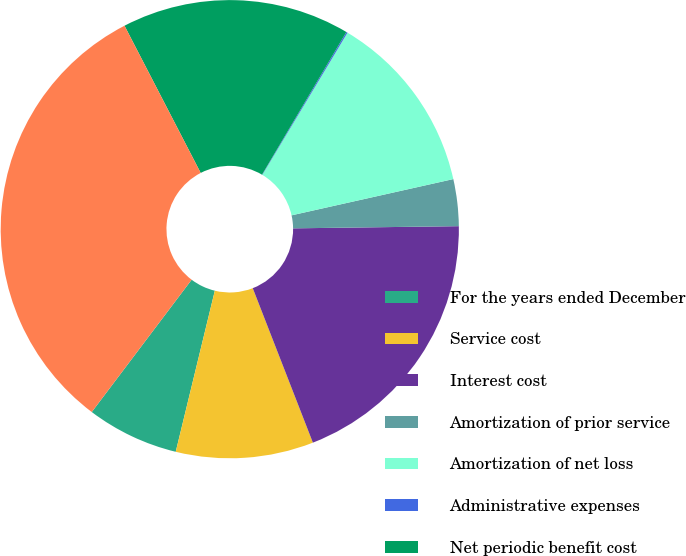Convert chart. <chart><loc_0><loc_0><loc_500><loc_500><pie_chart><fcel>For the years ended December<fcel>Service cost<fcel>Interest cost<fcel>Amortization of prior service<fcel>Amortization of net loss<fcel>Administrative expenses<fcel>Net periodic benefit cost<fcel>Total amount reflected in<nl><fcel>6.5%<fcel>9.7%<fcel>19.3%<fcel>3.3%<fcel>12.9%<fcel>0.09%<fcel>16.1%<fcel>32.11%<nl></chart> 